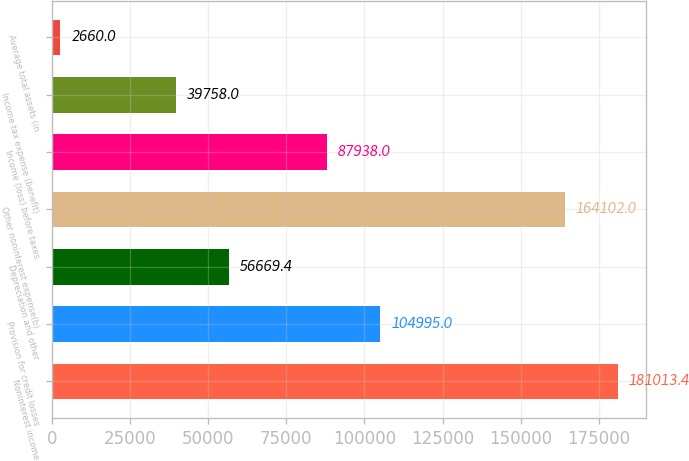Convert chart. <chart><loc_0><loc_0><loc_500><loc_500><bar_chart><fcel>Noninterest income<fcel>Provision for credit losses<fcel>Depreciation and other<fcel>Other noninterest expense(b)<fcel>Income (loss) before taxes<fcel>Income tax expense (benefit)<fcel>Average total assets (in<nl><fcel>181013<fcel>104995<fcel>56669.4<fcel>164102<fcel>87938<fcel>39758<fcel>2660<nl></chart> 